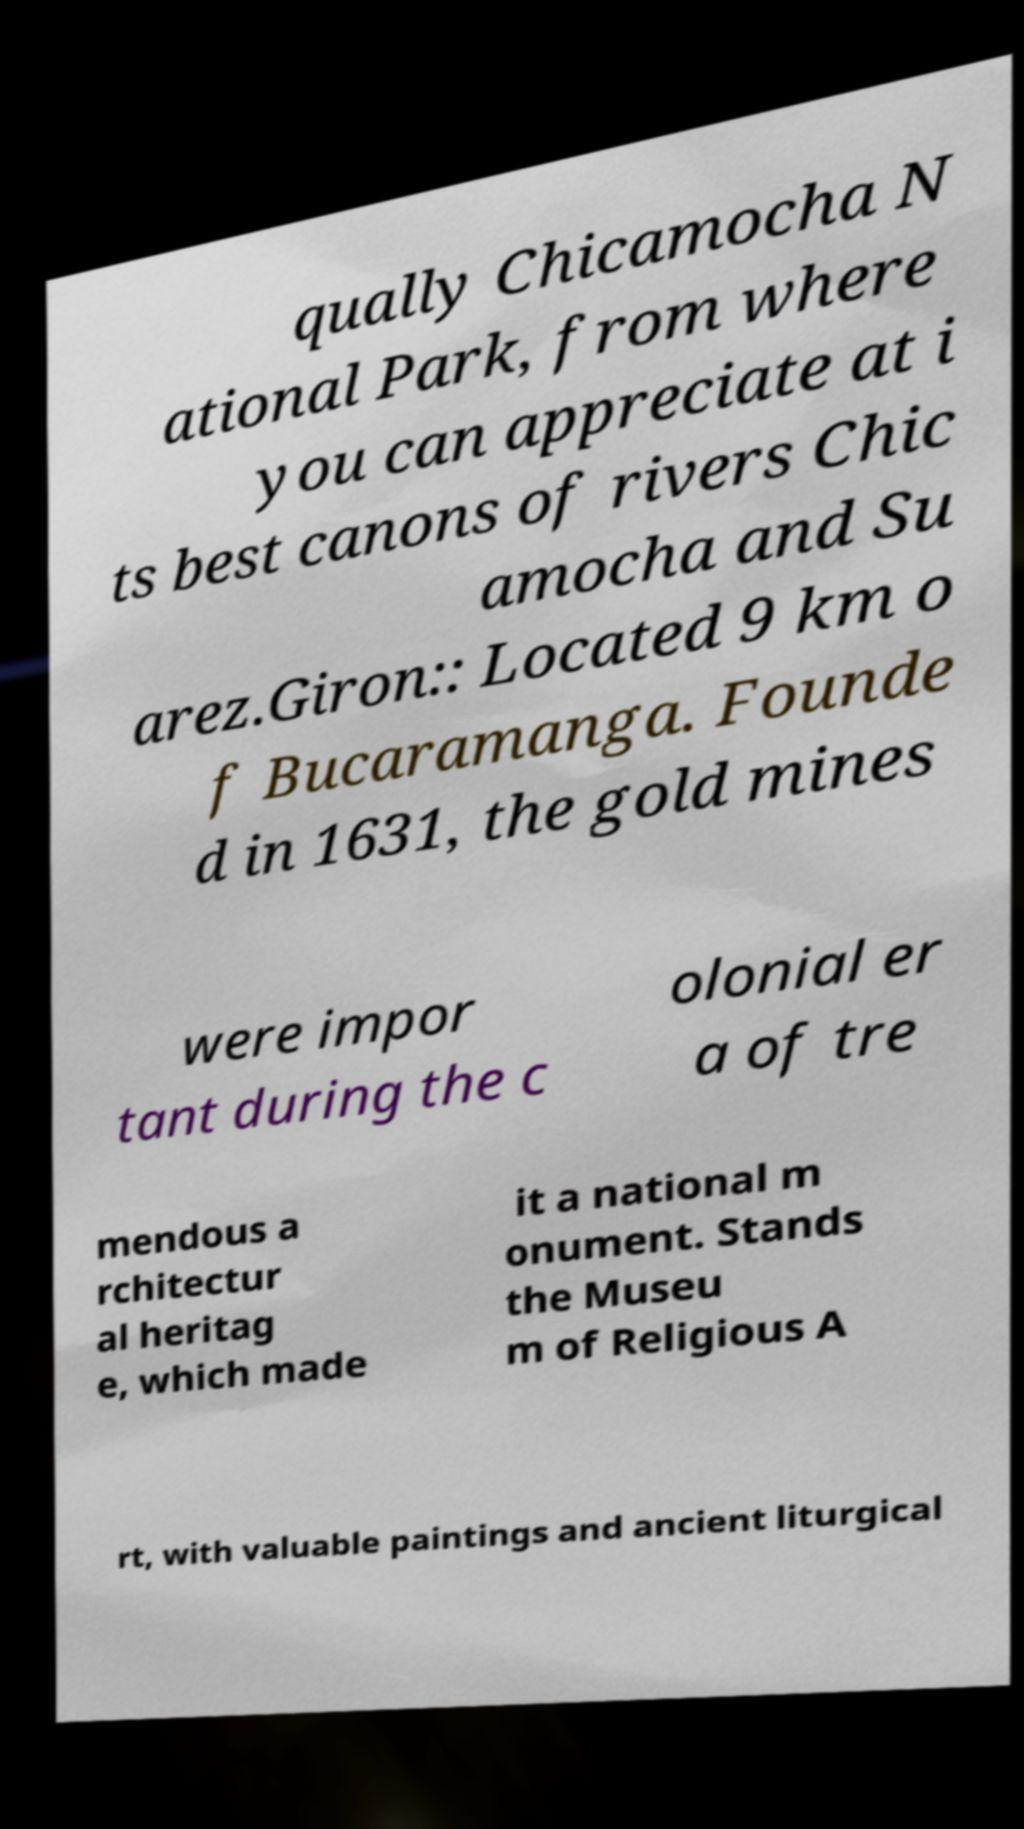Could you extract and type out the text from this image? qually Chicamocha N ational Park, from where you can appreciate at i ts best canons of rivers Chic amocha and Su arez.Giron:: Located 9 km o f Bucaramanga. Founde d in 1631, the gold mines were impor tant during the c olonial er a of tre mendous a rchitectur al heritag e, which made it a national m onument. Stands the Museu m of Religious A rt, with valuable paintings and ancient liturgical 